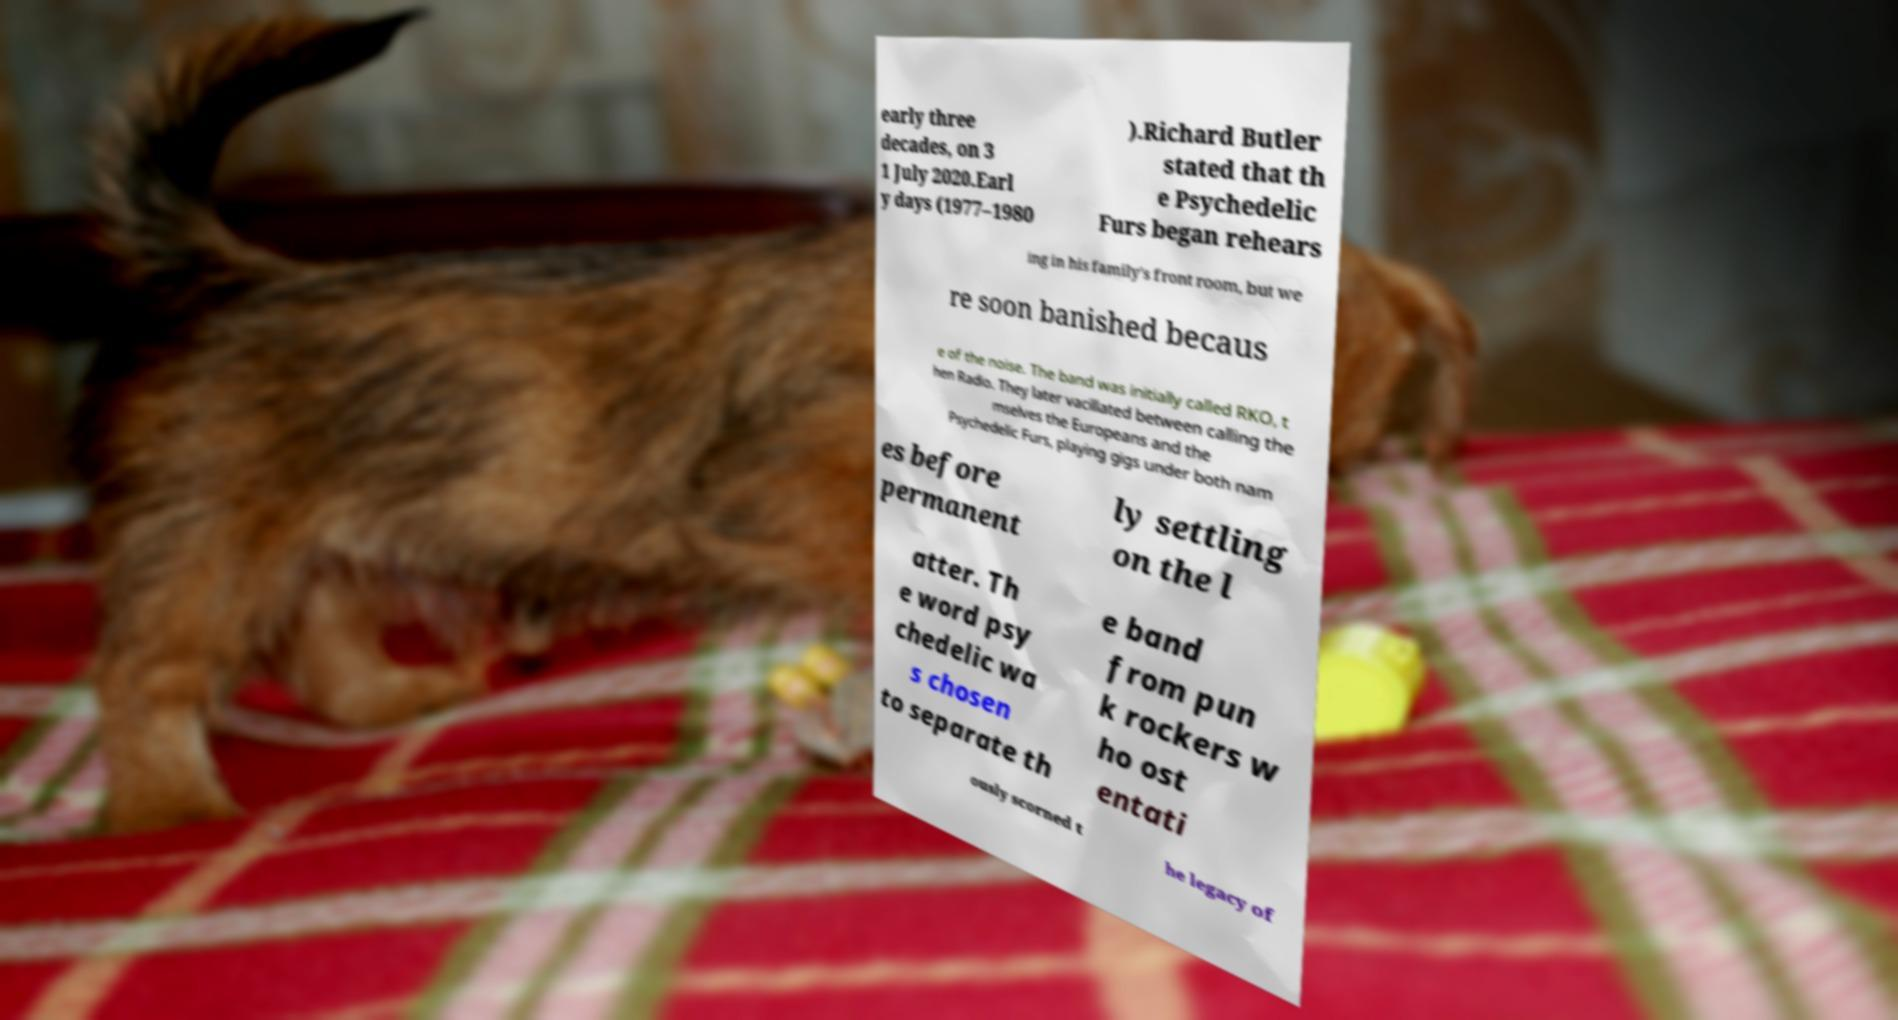What messages or text are displayed in this image? I need them in a readable, typed format. early three decades, on 3 1 July 2020.Earl y days (1977–1980 ).Richard Butler stated that th e Psychedelic Furs began rehears ing in his family's front room, but we re soon banished becaus e of the noise. The band was initially called RKO, t hen Radio. They later vacillated between calling the mselves the Europeans and the Psychedelic Furs, playing gigs under both nam es before permanent ly settling on the l atter. Th e word psy chedelic wa s chosen to separate th e band from pun k rockers w ho ost entati ously scorned t he legacy of 